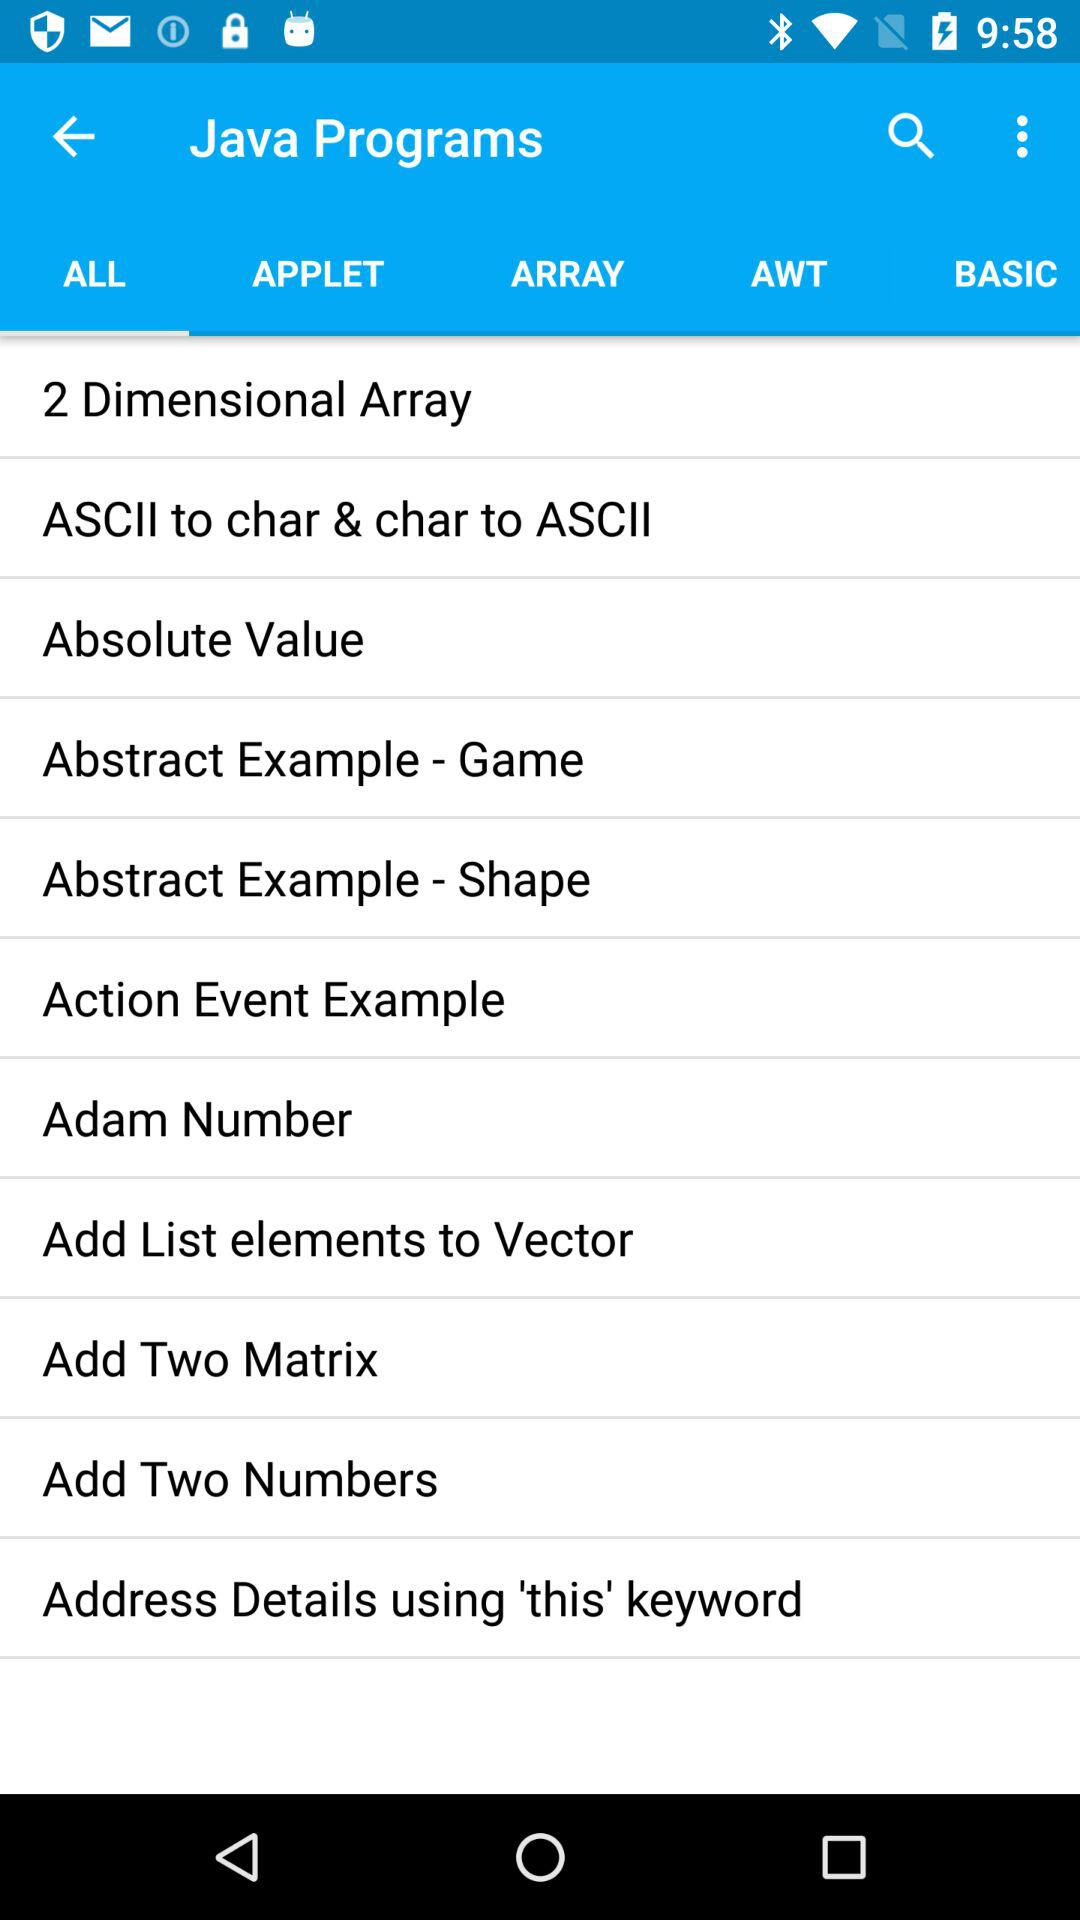Which tab has been selected? The selected tab is "ALL". 